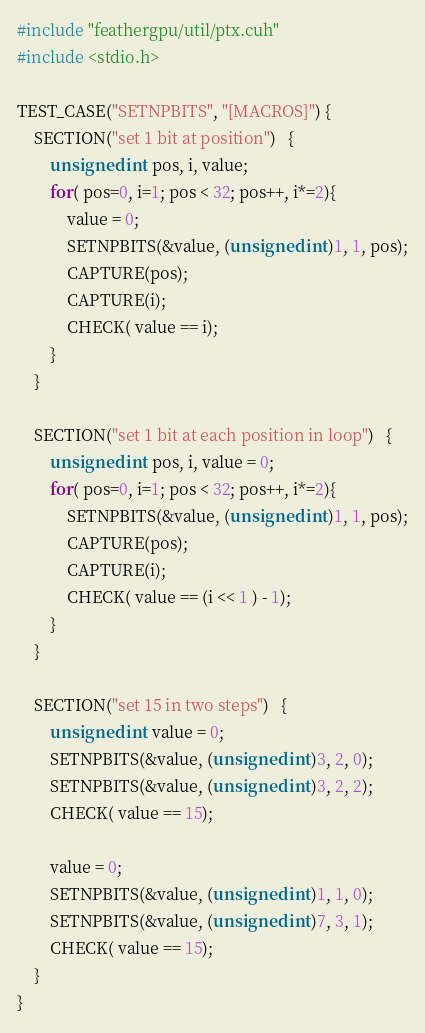<code> <loc_0><loc_0><loc_500><loc_500><_Cuda_>#include "feathergpu/util/ptx.cuh"
#include <stdio.h>

TEST_CASE("SETNPBITS", "[MACROS]") {
    SECTION("set 1 bit at position")   {
        unsigned int pos, i, value;
        for( pos=0, i=1; pos < 32; pos++, i*=2){
            value = 0;
            SETNPBITS(&value, (unsigned int)1, 1, pos);
            CAPTURE(pos);
            CAPTURE(i);
            CHECK( value == i);
        }
    }

    SECTION("set 1 bit at each position in loop")   {
        unsigned int pos, i, value = 0;
        for( pos=0, i=1; pos < 32; pos++, i*=2){
            SETNPBITS(&value, (unsigned int)1, 1, pos);
            CAPTURE(pos);
            CAPTURE(i);
            CHECK( value == (i << 1 ) - 1);
        }
    }

    SECTION("set 15 in two steps")   {
        unsigned int value = 0;
        SETNPBITS(&value, (unsigned int)3, 2, 0);
        SETNPBITS(&value, (unsigned int)3, 2, 2);
        CHECK( value == 15);

        value = 0;
        SETNPBITS(&value, (unsigned int)1, 1, 0);
        SETNPBITS(&value, (unsigned int)7, 3, 1);
        CHECK( value == 15);
    }
}
</code> 